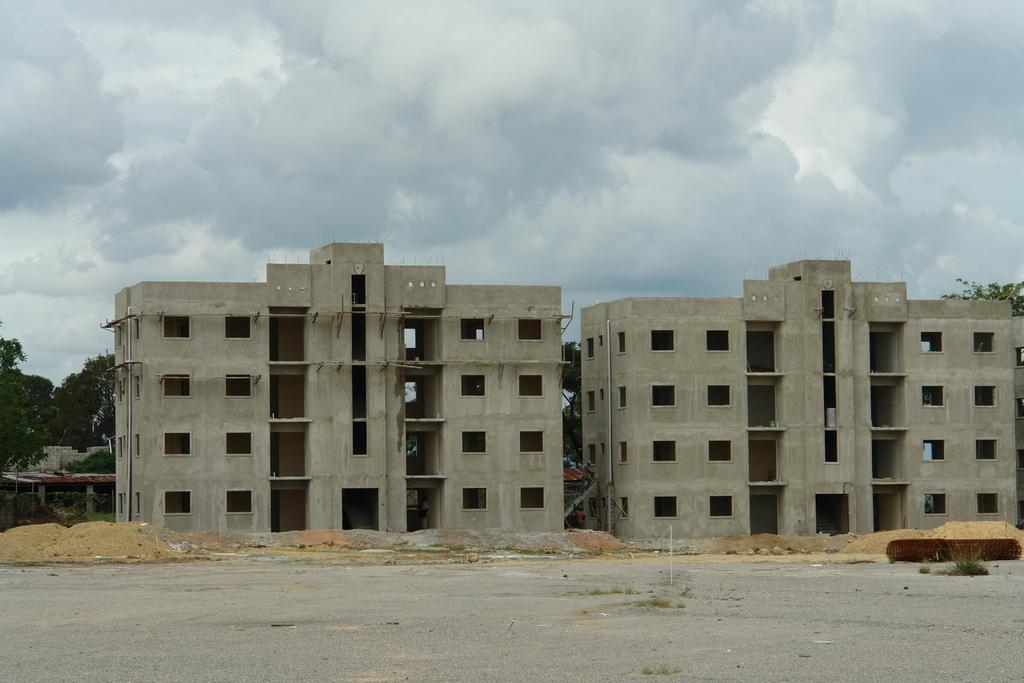What structures are located in the middle of the image? There are buildings in the middle of the image. What type of natural elements can be seen in the background of the image? There are trees in the background of the image. What is visible at the top of the image? The sky is visible at the top of the image. What type of ship can be seen sailing in the image? There is no ship present in the image; it features buildings, trees, and the sky. What is the profit margin of the buildings in the image? There is no information about the profit margin of the buildings in the image, as it is not relevant to the visual content. 